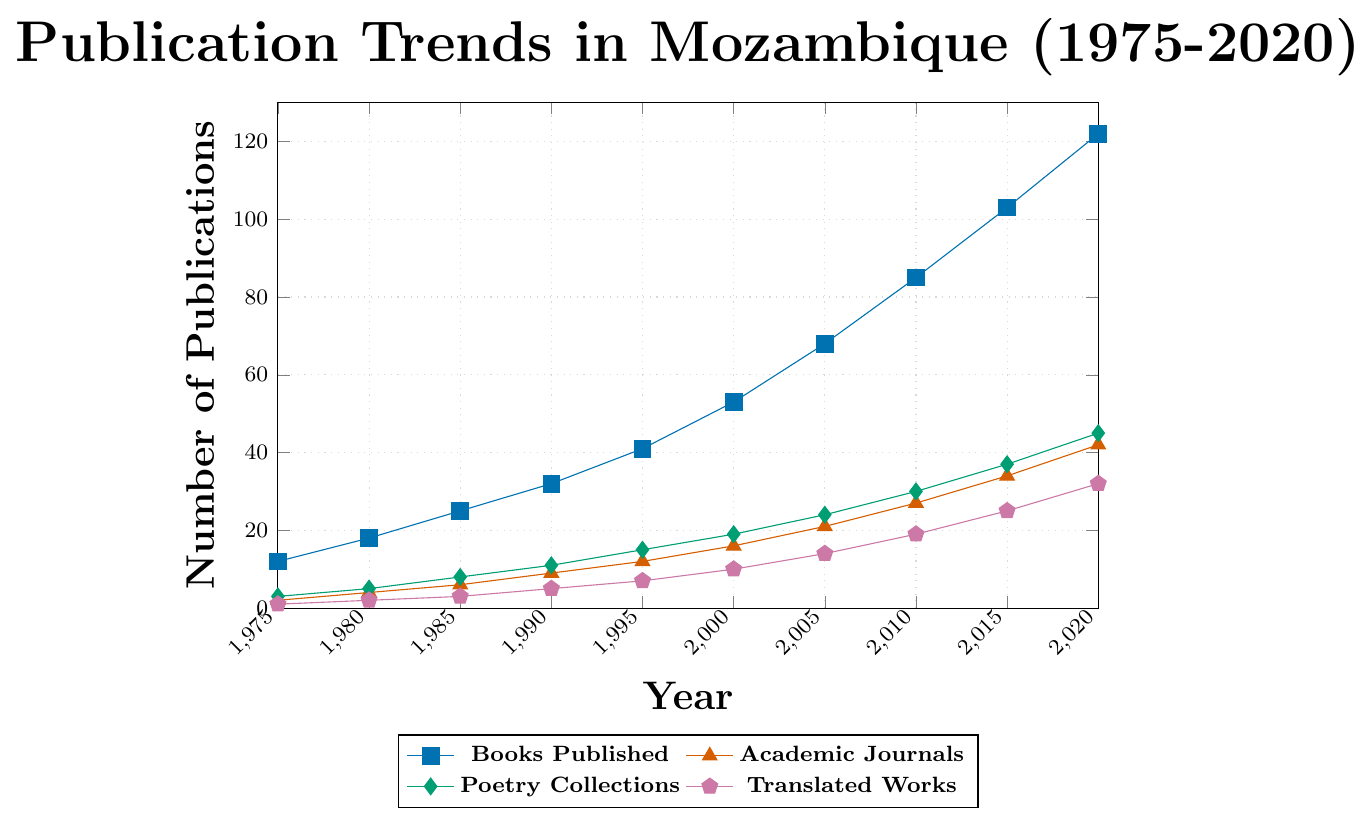What is the overall trend for books published in Mozambique from 1975 to 2020? The overall trend for books published in Mozambique shows a consistent increase every five years. Starting from 12 books published in 1975, it rises to 122 books in 2020.
Answer: Increasing What was the difference in the number of academic journals published between 1990 and 2020? In 1990, 9 academic journals were published, and in 2020, 42 academic journals were published. The difference is 42 - 9 = 33.
Answer: 33 Which category saw the most substantial increase from 1975 to 2020? From the chart, all categories show an increase. To identify the most substantial increase, compare the values: 
Books published: 122 - 12 = 110
Academic journals: 42 - 2 = 40
Poetry collections: 45 - 3 = 42
Translated works: 32 - 1 = 31
The category with the most significant increase is "Books Published" with an increase of 110.
Answer: Books Published In what year did the number of poetry collections first exceed 20? The line representing poetry collections shows that it first exceeds 20 in the year 2005.
Answer: 2005 How many total publications (books, academic journals, poetry collections, and translated works) were there in 2000? Sum the number of each type of publication for the year 2000: 53 (Books Published) + 16 (Academic Journals) + 19 (Poetry Collections) + 10 (Translated Works) = 98.
Answer: 98 By how much did the number of translated works increase between 2015 and 2020? In 2015, 25 translated works were published, and in 2020, 32 translated works were published. The increase is 32 - 25 = 7.
Answer: 7 Between which two consecutive years did books published see the largest increase? Examine the increase between consecutive years:
1980 - 1975: 18 - 12 = 6
1985 - 1980: 25 - 18 = 7
1990 - 1985: 32 - 25 = 7
1995 - 1990: 41 - 32 = 9
2000 - 1995: 53 - 41 = 12
2005 - 2000: 68 - 53 = 15
2010 - 2005: 85 - 68 = 17
2015 - 2010: 103 - 85 = 18
2020 - 2015: 122 - 103 = 19
The largest increase happened between 2015 and 2020, with an increase of 19.
Answer: 2015 and 2020 What is the average number of academic journals published per year between 1975 and 2020? There are ten data points (from 1975 to 2020, every five years): Sum them up: 2 + 4 + 6 + 9 + 12 + 16 + 21 + 27 + 34 + 42 = 173. The average is 173 / 10 = 17.3.
Answer: 17.3 Compare the rate of increase in poetry collections and translated works from 2000 to 2020. Calculate the increments first:
Poetry collections: 45 - 19 = 26
Translated works: 32 - 10 = 22
Poetry collections increased by 26, while translated works increased by 22. Thus, poetry collections had a slightly higher rate of increase.
Answer: Poetry collections What color represents translated works in the chart? Referring to the legend, translated works are represented by the pentagon symbol which is in pink.
Answer: Pink 